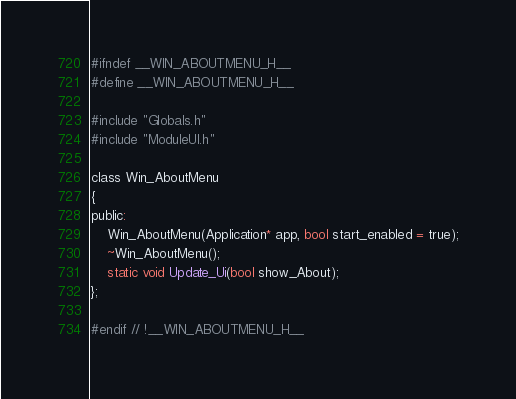Convert code to text. <code><loc_0><loc_0><loc_500><loc_500><_C_>#ifndef __WIN_ABOUTMENU_H__
#define __WIN_ABOUTMENU_H__

#include "Globals.h"
#include "ModuleUI.h"

class Win_AboutMenu
{
public:
	Win_AboutMenu(Application* app, bool start_enabled = true);
	~Win_AboutMenu();
	static void Update_Ui(bool show_About);
};

#endif // !__WIN_ABOUTMENU_H__
</code> 